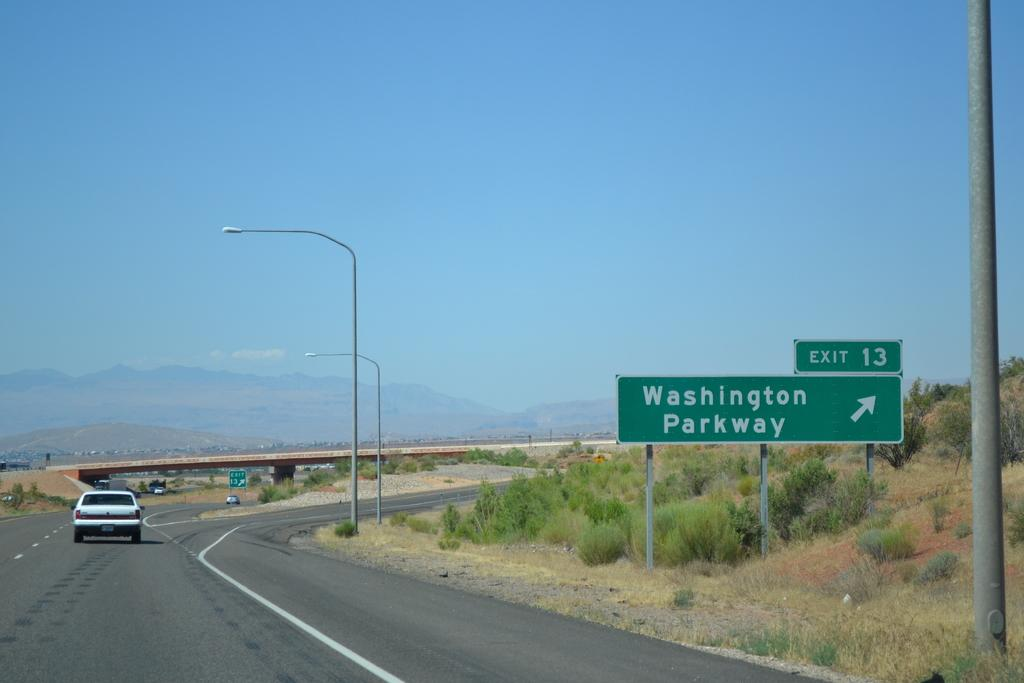<image>
Write a terse but informative summary of the picture. A road sign that shows that the exit for Washington Parkway is on the right. 